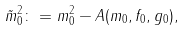<formula> <loc_0><loc_0><loc_500><loc_500>\tilde { m } _ { 0 } ^ { 2 } \colon = m _ { 0 } ^ { 2 } - A ( m _ { 0 } , f _ { 0 } , g _ { 0 } ) ,</formula> 